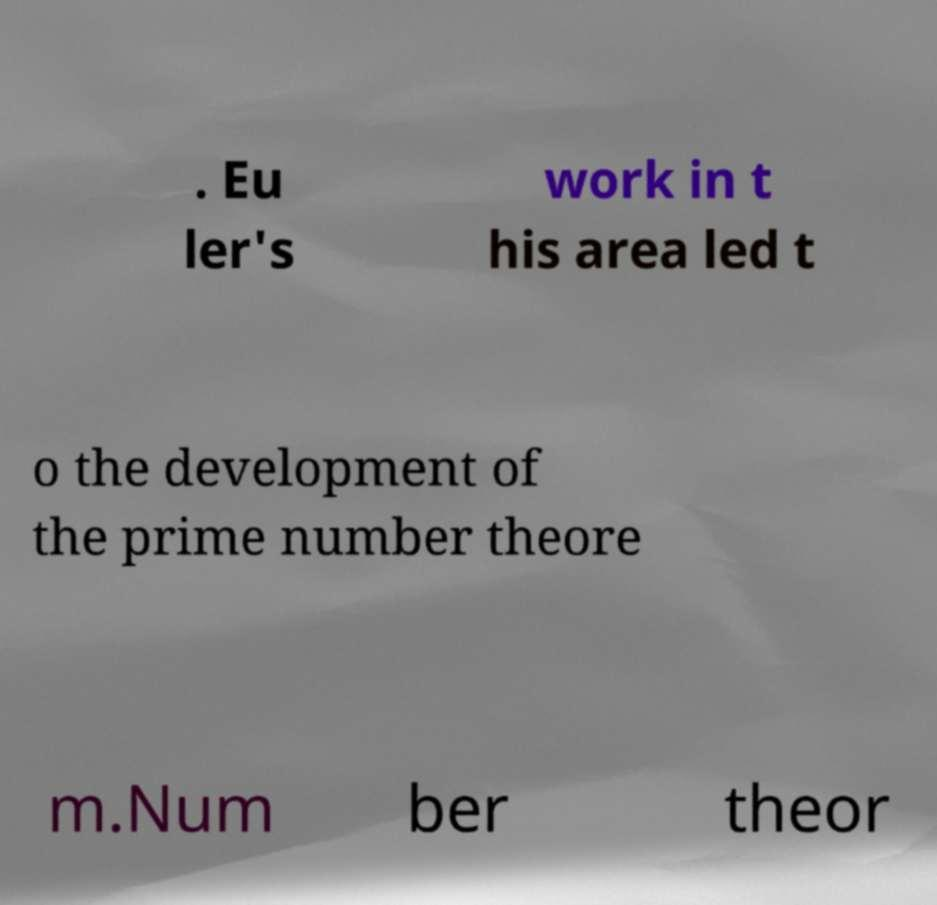There's text embedded in this image that I need extracted. Can you transcribe it verbatim? . Eu ler's work in t his area led t o the development of the prime number theore m.Num ber theor 